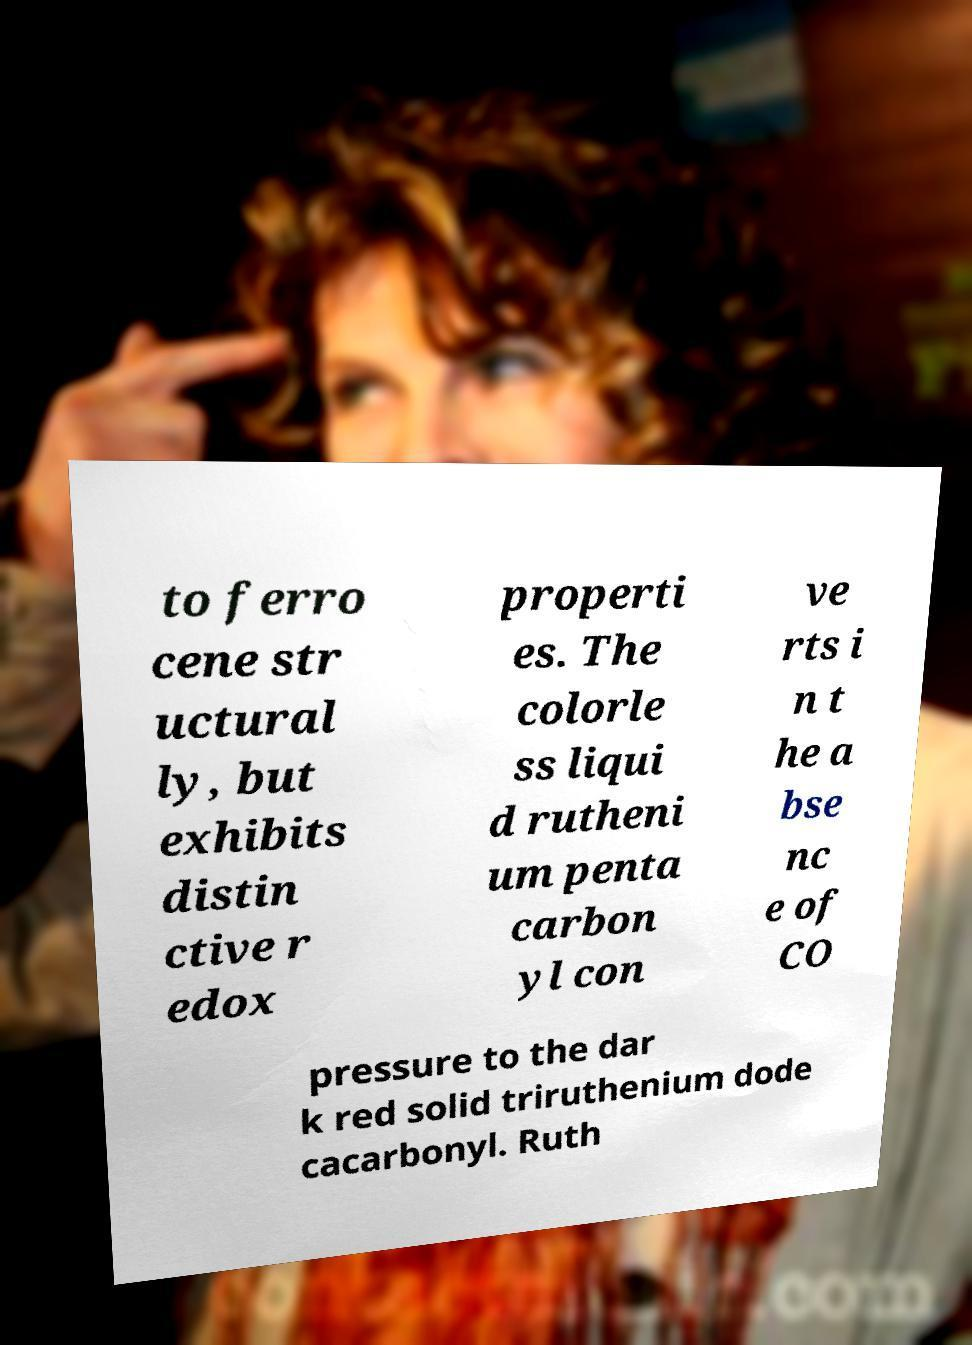Could you extract and type out the text from this image? to ferro cene str uctural ly, but exhibits distin ctive r edox properti es. The colorle ss liqui d rutheni um penta carbon yl con ve rts i n t he a bse nc e of CO pressure to the dar k red solid triruthenium dode cacarbonyl. Ruth 